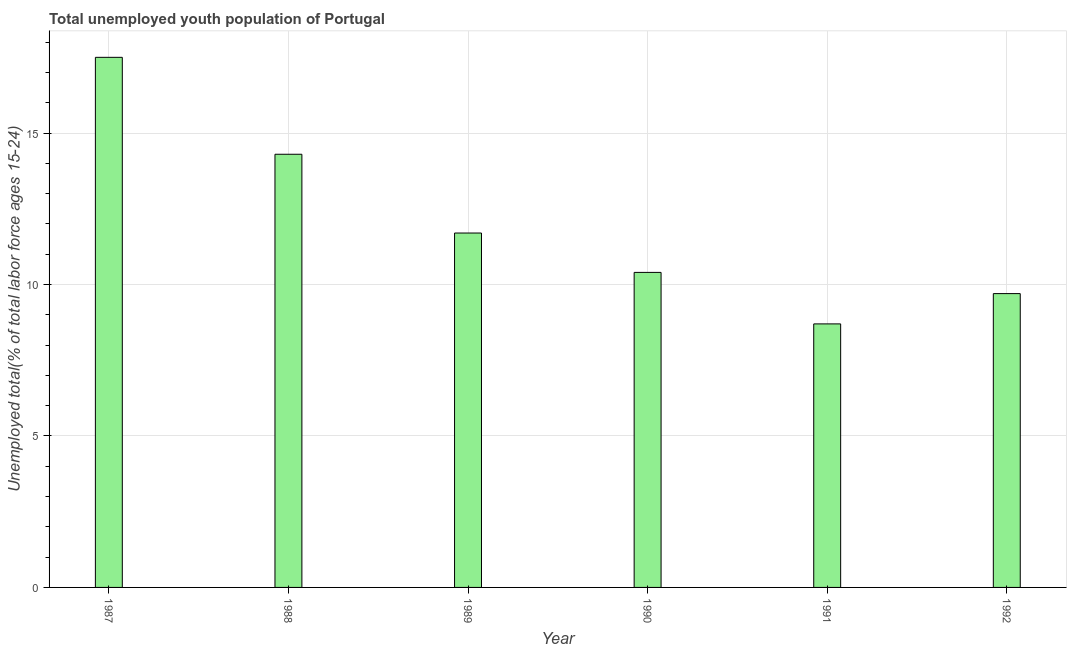Does the graph contain any zero values?
Offer a very short reply. No. What is the title of the graph?
Give a very brief answer. Total unemployed youth population of Portugal. What is the label or title of the Y-axis?
Provide a succinct answer. Unemployed total(% of total labor force ages 15-24). What is the unemployed youth in 1992?
Your answer should be compact. 9.7. Across all years, what is the minimum unemployed youth?
Ensure brevity in your answer.  8.7. In which year was the unemployed youth maximum?
Give a very brief answer. 1987. In which year was the unemployed youth minimum?
Your answer should be very brief. 1991. What is the sum of the unemployed youth?
Provide a short and direct response. 72.3. What is the difference between the unemployed youth in 1990 and 1992?
Ensure brevity in your answer.  0.7. What is the average unemployed youth per year?
Offer a terse response. 12.05. What is the median unemployed youth?
Ensure brevity in your answer.  11.05. What is the ratio of the unemployed youth in 1989 to that in 1992?
Offer a very short reply. 1.21. What is the difference between the highest and the second highest unemployed youth?
Ensure brevity in your answer.  3.2. Is the sum of the unemployed youth in 1989 and 1991 greater than the maximum unemployed youth across all years?
Offer a terse response. Yes. In how many years, is the unemployed youth greater than the average unemployed youth taken over all years?
Give a very brief answer. 2. How many bars are there?
Your answer should be very brief. 6. How many years are there in the graph?
Give a very brief answer. 6. What is the difference between two consecutive major ticks on the Y-axis?
Your answer should be compact. 5. Are the values on the major ticks of Y-axis written in scientific E-notation?
Give a very brief answer. No. What is the Unemployed total(% of total labor force ages 15-24) of 1987?
Your answer should be compact. 17.5. What is the Unemployed total(% of total labor force ages 15-24) of 1988?
Keep it short and to the point. 14.3. What is the Unemployed total(% of total labor force ages 15-24) of 1989?
Provide a short and direct response. 11.7. What is the Unemployed total(% of total labor force ages 15-24) in 1990?
Your answer should be very brief. 10.4. What is the Unemployed total(% of total labor force ages 15-24) of 1991?
Provide a short and direct response. 8.7. What is the Unemployed total(% of total labor force ages 15-24) of 1992?
Give a very brief answer. 9.7. What is the difference between the Unemployed total(% of total labor force ages 15-24) in 1987 and 1989?
Provide a succinct answer. 5.8. What is the difference between the Unemployed total(% of total labor force ages 15-24) in 1987 and 1990?
Your answer should be compact. 7.1. What is the difference between the Unemployed total(% of total labor force ages 15-24) in 1987 and 1991?
Ensure brevity in your answer.  8.8. What is the difference between the Unemployed total(% of total labor force ages 15-24) in 1988 and 1989?
Ensure brevity in your answer.  2.6. What is the difference between the Unemployed total(% of total labor force ages 15-24) in 1988 and 1991?
Your answer should be very brief. 5.6. What is the difference between the Unemployed total(% of total labor force ages 15-24) in 1989 and 1992?
Keep it short and to the point. 2. What is the difference between the Unemployed total(% of total labor force ages 15-24) in 1990 and 1991?
Your answer should be very brief. 1.7. What is the difference between the Unemployed total(% of total labor force ages 15-24) in 1991 and 1992?
Offer a very short reply. -1. What is the ratio of the Unemployed total(% of total labor force ages 15-24) in 1987 to that in 1988?
Your answer should be compact. 1.22. What is the ratio of the Unemployed total(% of total labor force ages 15-24) in 1987 to that in 1989?
Offer a very short reply. 1.5. What is the ratio of the Unemployed total(% of total labor force ages 15-24) in 1987 to that in 1990?
Keep it short and to the point. 1.68. What is the ratio of the Unemployed total(% of total labor force ages 15-24) in 1987 to that in 1991?
Provide a short and direct response. 2.01. What is the ratio of the Unemployed total(% of total labor force ages 15-24) in 1987 to that in 1992?
Ensure brevity in your answer.  1.8. What is the ratio of the Unemployed total(% of total labor force ages 15-24) in 1988 to that in 1989?
Offer a terse response. 1.22. What is the ratio of the Unemployed total(% of total labor force ages 15-24) in 1988 to that in 1990?
Your answer should be very brief. 1.38. What is the ratio of the Unemployed total(% of total labor force ages 15-24) in 1988 to that in 1991?
Provide a short and direct response. 1.64. What is the ratio of the Unemployed total(% of total labor force ages 15-24) in 1988 to that in 1992?
Make the answer very short. 1.47. What is the ratio of the Unemployed total(% of total labor force ages 15-24) in 1989 to that in 1991?
Provide a succinct answer. 1.34. What is the ratio of the Unemployed total(% of total labor force ages 15-24) in 1989 to that in 1992?
Keep it short and to the point. 1.21. What is the ratio of the Unemployed total(% of total labor force ages 15-24) in 1990 to that in 1991?
Your answer should be compact. 1.2. What is the ratio of the Unemployed total(% of total labor force ages 15-24) in 1990 to that in 1992?
Offer a terse response. 1.07. What is the ratio of the Unemployed total(% of total labor force ages 15-24) in 1991 to that in 1992?
Your answer should be compact. 0.9. 